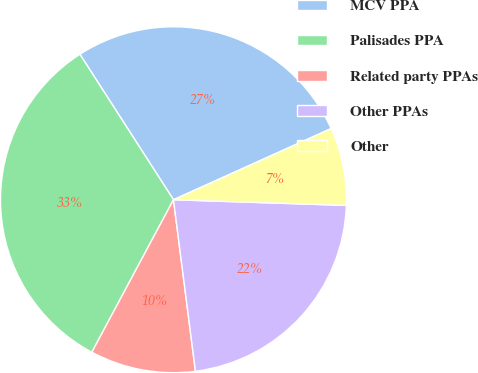<chart> <loc_0><loc_0><loc_500><loc_500><pie_chart><fcel>MCV PPA<fcel>Palisades PPA<fcel>Related party PPAs<fcel>Other PPAs<fcel>Other<nl><fcel>27.35%<fcel>33.08%<fcel>9.85%<fcel>22.45%<fcel>7.27%<nl></chart> 